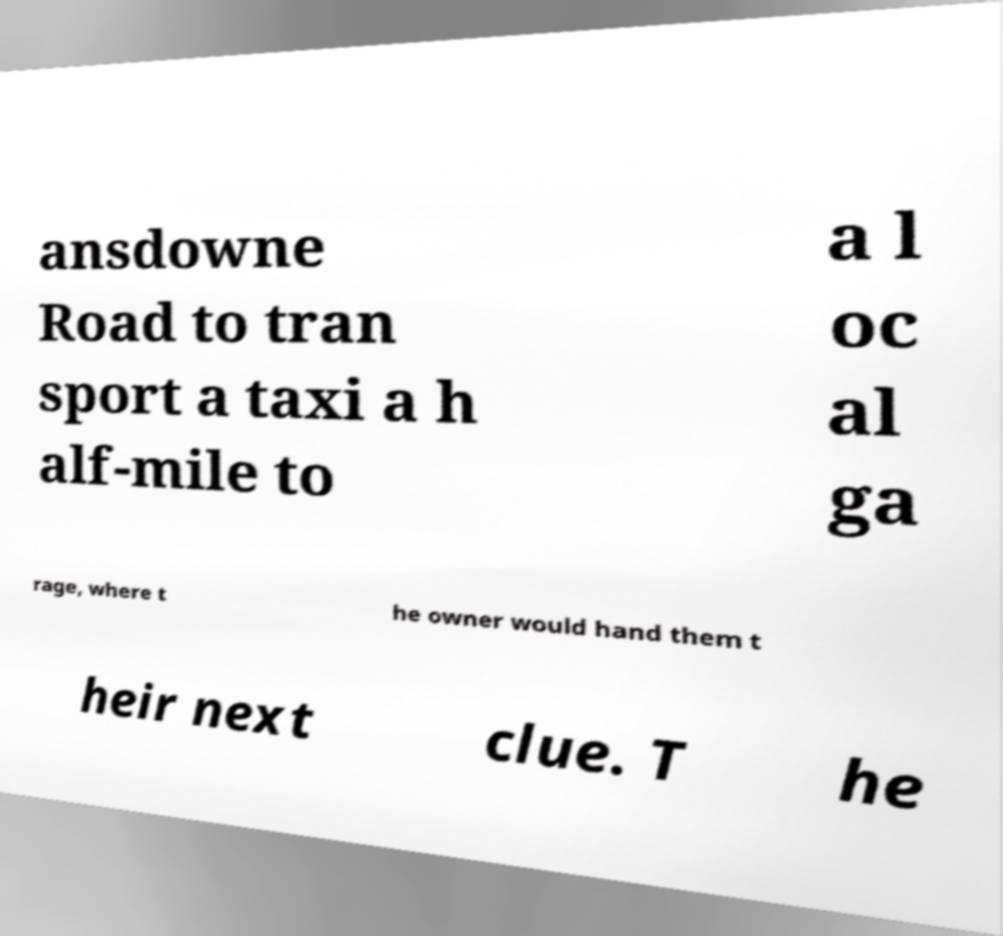Could you extract and type out the text from this image? ansdowne Road to tran sport a taxi a h alf-mile to a l oc al ga rage, where t he owner would hand them t heir next clue. T he 